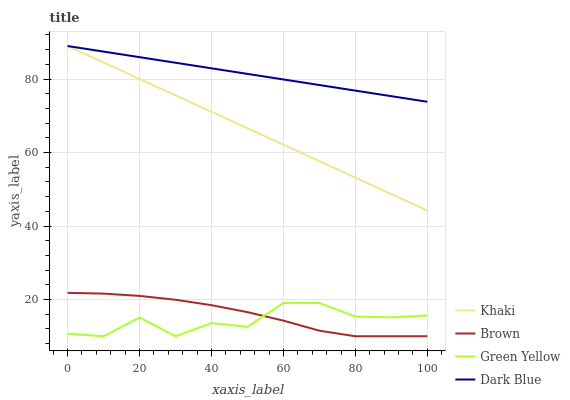Does Khaki have the minimum area under the curve?
Answer yes or no. No. Does Khaki have the maximum area under the curve?
Answer yes or no. No. Is Green Yellow the smoothest?
Answer yes or no. No. Is Khaki the roughest?
Answer yes or no. No. Does Khaki have the lowest value?
Answer yes or no. No. Does Green Yellow have the highest value?
Answer yes or no. No. Is Green Yellow less than Dark Blue?
Answer yes or no. Yes. Is Khaki greater than Green Yellow?
Answer yes or no. Yes. Does Green Yellow intersect Dark Blue?
Answer yes or no. No. 